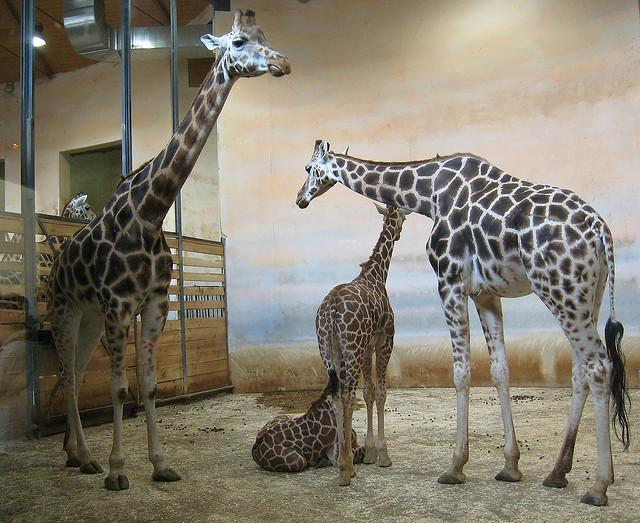What kind of venue is this? Please explain your reasoning. giraffe barn. The animals have four legs and long necks. they are inside a building. 